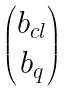Convert formula to latex. <formula><loc_0><loc_0><loc_500><loc_500>\begin{pmatrix} b _ { c l } \\ b _ { q } \end{pmatrix}</formula> 